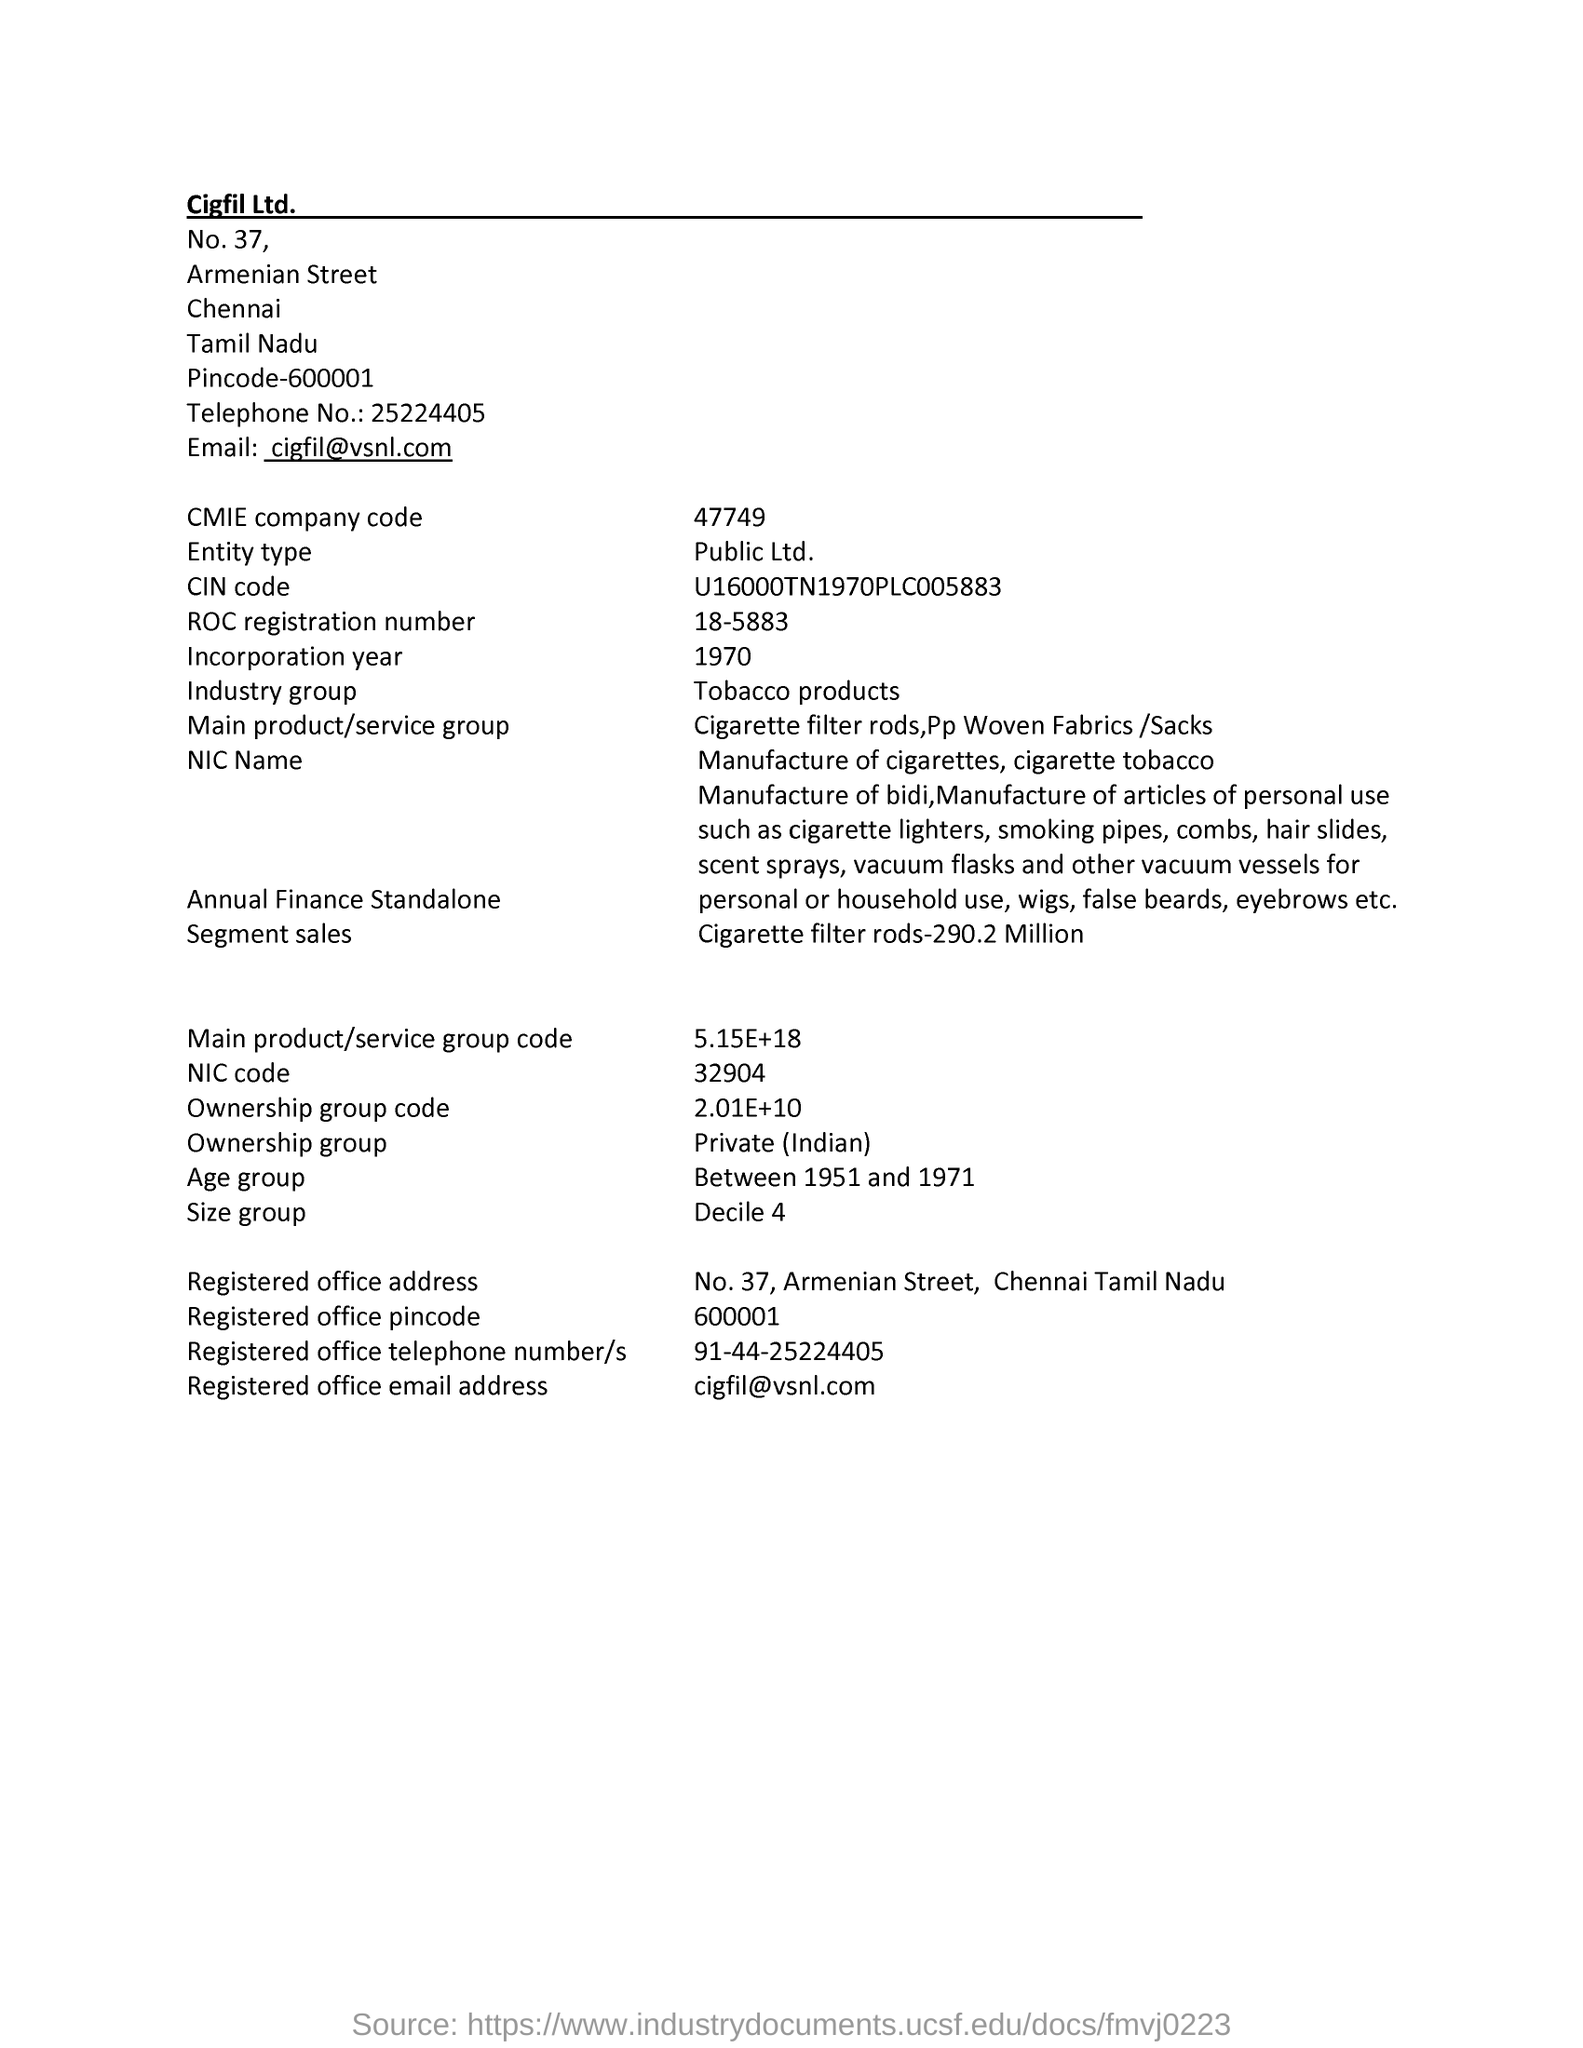What is the cmie company code mentioned in the page ?
Offer a terse response. 47749. What is the roc registration number given in the page ?
Give a very brief answer. 18-5883. What is the registered telephone number/s mentioned in the page ?
Make the answer very short. 91-44-25224405. What is the industry group mentioned in the page ?
Give a very brief answer. Tobacco products. What is the age group mentioned in the page ?
Offer a terse response. Between 1951 and 1971. What is the incorporation year mentioned in the given page ?
Your response must be concise. 1970. What is the  nic code given in the page ?
Provide a succinct answer. 32904. 